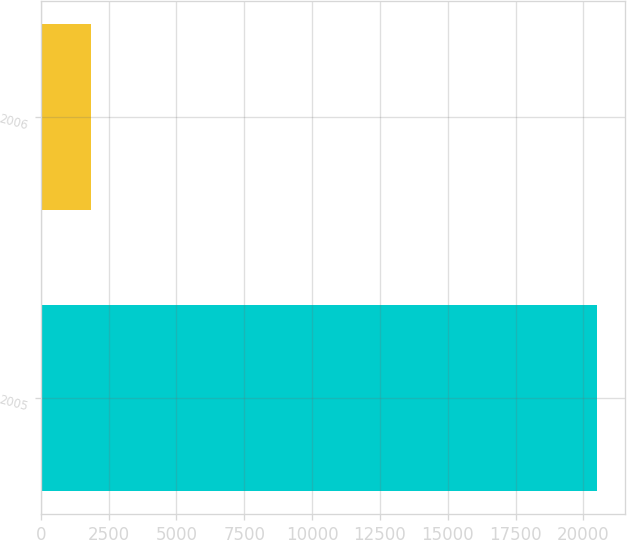Convert chart to OTSL. <chart><loc_0><loc_0><loc_500><loc_500><bar_chart><fcel>2005<fcel>2006<nl><fcel>20519<fcel>1865<nl></chart> 